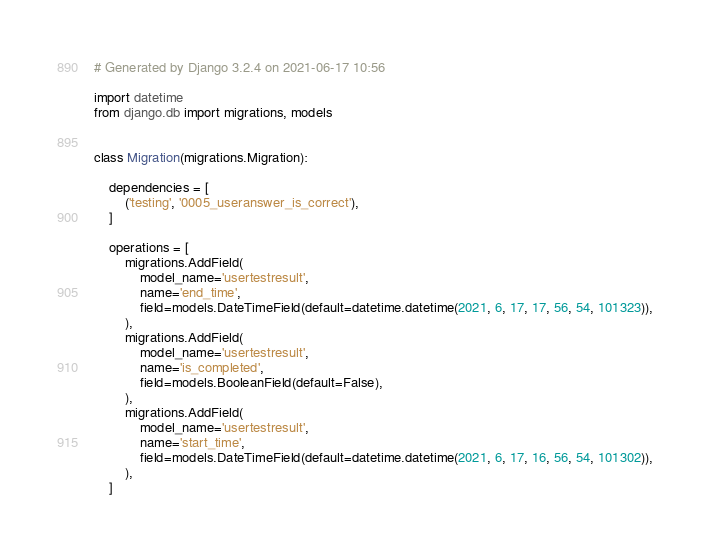Convert code to text. <code><loc_0><loc_0><loc_500><loc_500><_Python_># Generated by Django 3.2.4 on 2021-06-17 10:56

import datetime
from django.db import migrations, models


class Migration(migrations.Migration):

    dependencies = [
        ('testing', '0005_useranswer_is_correct'),
    ]

    operations = [
        migrations.AddField(
            model_name='usertestresult',
            name='end_time',
            field=models.DateTimeField(default=datetime.datetime(2021, 6, 17, 17, 56, 54, 101323)),
        ),
        migrations.AddField(
            model_name='usertestresult',
            name='is_completed',
            field=models.BooleanField(default=False),
        ),
        migrations.AddField(
            model_name='usertestresult',
            name='start_time',
            field=models.DateTimeField(default=datetime.datetime(2021, 6, 17, 16, 56, 54, 101302)),
        ),
    ]
</code> 